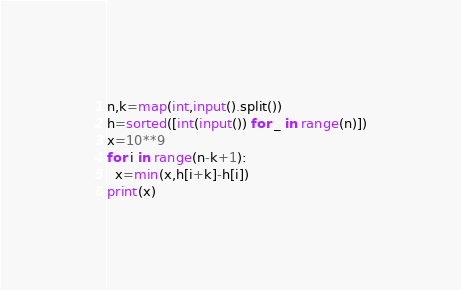Convert code to text. <code><loc_0><loc_0><loc_500><loc_500><_Python_>n,k=map(int,input().split())
h=sorted([int(input()) for _ in range(n)])
x=10**9
for i in range(n-k+1):
  x=min(x,h[i+k]-h[i])
print(x)</code> 